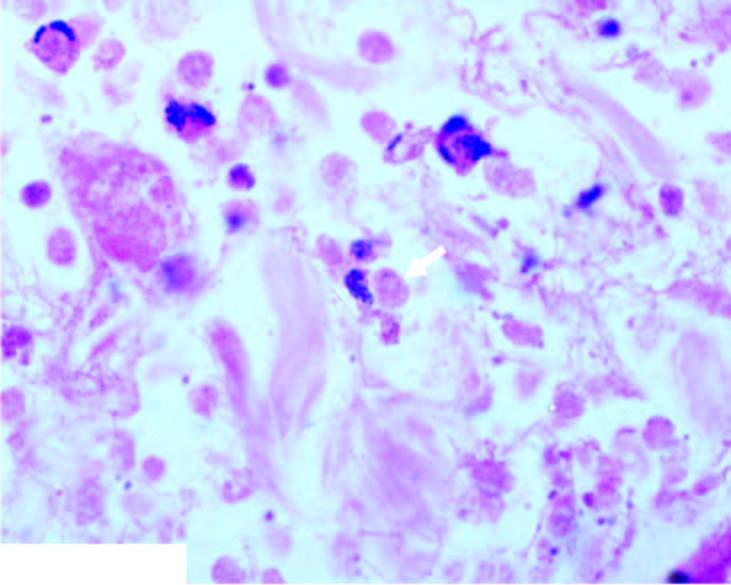what shows necrotic debris, acute inflammatory infiltrate and a few trophozoites of entamoeba histolytica?
Answer the question using a single word or phrase. Section from margin amoebic ulcer 